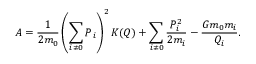Convert formula to latex. <formula><loc_0><loc_0><loc_500><loc_500>A = \frac { 1 } { 2 m _ { 0 } } \left ( \sum _ { i \ne 0 } P _ { i } \right ) ^ { 2 } K ( Q ) + \sum _ { i \ne 0 } \frac { P _ { i } ^ { 2 } } { 2 m _ { i } } - \frac { G m _ { 0 } m _ { i } } { Q _ { i } } .</formula> 